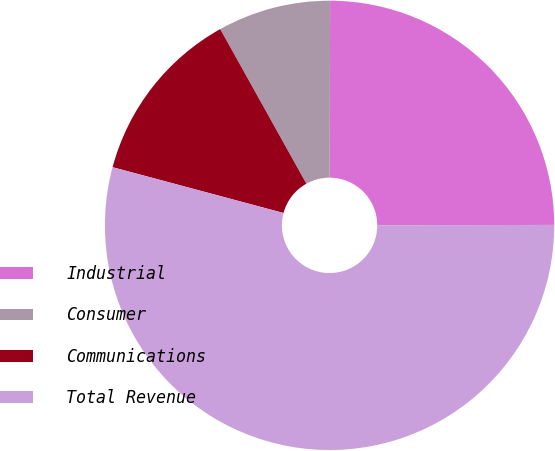Convert chart. <chart><loc_0><loc_0><loc_500><loc_500><pie_chart><fcel>Industrial<fcel>Consumer<fcel>Communications<fcel>Total Revenue<nl><fcel>24.93%<fcel>8.13%<fcel>12.74%<fcel>54.2%<nl></chart> 